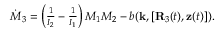Convert formula to latex. <formula><loc_0><loc_0><loc_500><loc_500>\begin{array} { r } { \dot { M } _ { 3 } = \left ( \frac { 1 } { I _ { 2 } } - \frac { 1 } { I _ { 1 } } \right ) M _ { 1 } M _ { 2 } - b ( { k } , [ { R } _ { 3 } ( t ) , { z } ( t ) ] ) . } \end{array}</formula> 